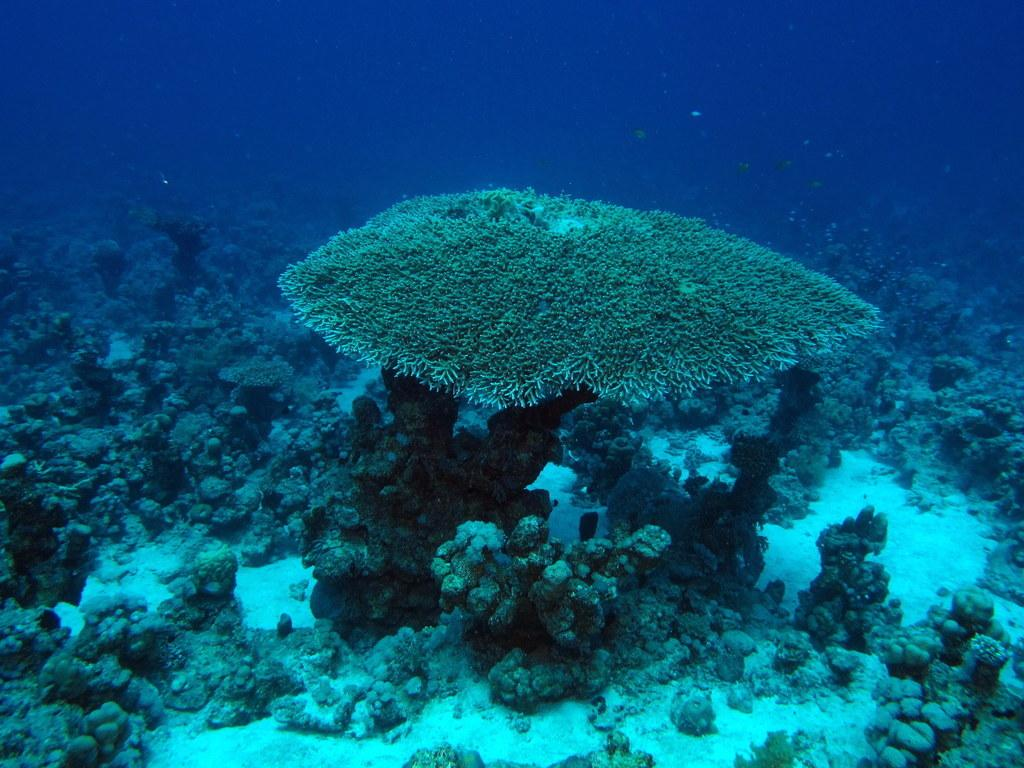What type of plants are in the image? There are plants in the water in the image. What type of butter can be seen on the plants in the image? There is no butter present on the plants in the image; it only features plants in the water. 